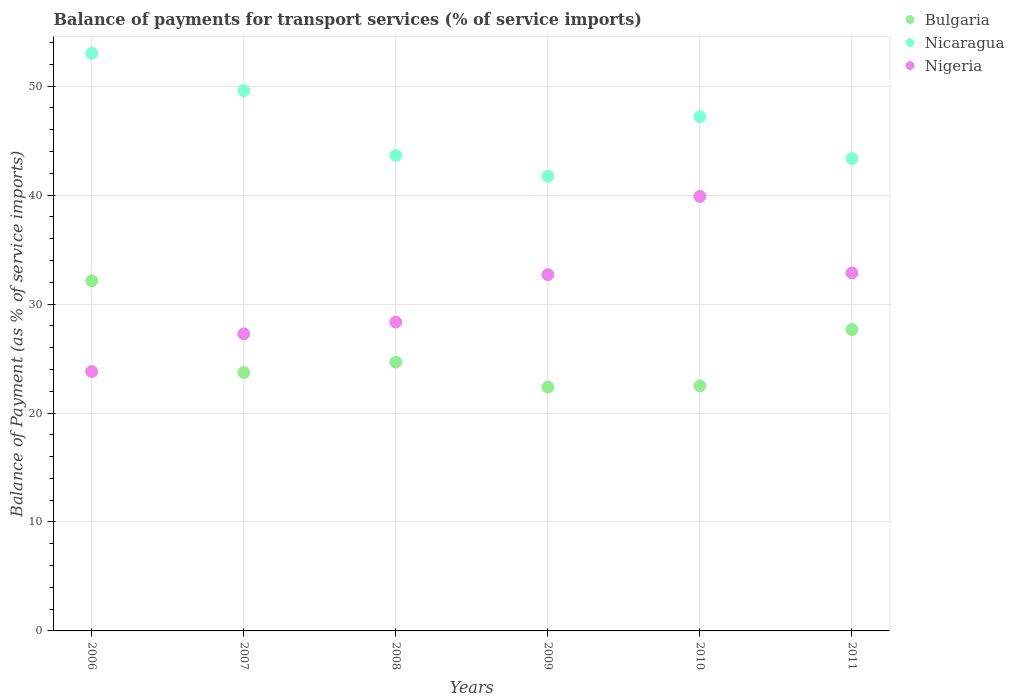What is the balance of payments for transport services in Nigeria in 2008?
Offer a terse response. 28.34. Across all years, what is the maximum balance of payments for transport services in Nigeria?
Keep it short and to the point. 39.87. Across all years, what is the minimum balance of payments for transport services in Bulgaria?
Your response must be concise. 22.37. In which year was the balance of payments for transport services in Nigeria maximum?
Your answer should be very brief. 2010. In which year was the balance of payments for transport services in Nicaragua minimum?
Provide a succinct answer. 2009. What is the total balance of payments for transport services in Nicaragua in the graph?
Offer a terse response. 278.52. What is the difference between the balance of payments for transport services in Nicaragua in 2006 and that in 2007?
Provide a short and direct response. 3.43. What is the difference between the balance of payments for transport services in Bulgaria in 2006 and the balance of payments for transport services in Nicaragua in 2008?
Offer a terse response. -11.5. What is the average balance of payments for transport services in Nicaragua per year?
Your answer should be very brief. 46.42. In the year 2011, what is the difference between the balance of payments for transport services in Nigeria and balance of payments for transport services in Bulgaria?
Provide a succinct answer. 5.19. In how many years, is the balance of payments for transport services in Nicaragua greater than 44 %?
Ensure brevity in your answer.  3. What is the ratio of the balance of payments for transport services in Nicaragua in 2007 to that in 2008?
Provide a succinct answer. 1.14. Is the balance of payments for transport services in Bulgaria in 2006 less than that in 2011?
Provide a short and direct response. No. What is the difference between the highest and the second highest balance of payments for transport services in Nicaragua?
Keep it short and to the point. 3.43. What is the difference between the highest and the lowest balance of payments for transport services in Nicaragua?
Give a very brief answer. 11.28. Is it the case that in every year, the sum of the balance of payments for transport services in Nigeria and balance of payments for transport services in Nicaragua  is greater than the balance of payments for transport services in Bulgaria?
Your answer should be compact. Yes. Is the balance of payments for transport services in Nicaragua strictly greater than the balance of payments for transport services in Nigeria over the years?
Offer a very short reply. Yes. Is the balance of payments for transport services in Nicaragua strictly less than the balance of payments for transport services in Nigeria over the years?
Ensure brevity in your answer.  No. How many years are there in the graph?
Your response must be concise. 6. Are the values on the major ticks of Y-axis written in scientific E-notation?
Your response must be concise. No. Does the graph contain any zero values?
Your answer should be compact. No. How many legend labels are there?
Provide a succinct answer. 3. How are the legend labels stacked?
Ensure brevity in your answer.  Vertical. What is the title of the graph?
Keep it short and to the point. Balance of payments for transport services (% of service imports). Does "Bhutan" appear as one of the legend labels in the graph?
Provide a short and direct response. No. What is the label or title of the Y-axis?
Your response must be concise. Balance of Payment (as % of service imports). What is the Balance of Payment (as % of service imports) of Bulgaria in 2006?
Offer a very short reply. 32.13. What is the Balance of Payment (as % of service imports) of Nicaragua in 2006?
Keep it short and to the point. 53.01. What is the Balance of Payment (as % of service imports) of Nigeria in 2006?
Offer a very short reply. 23.81. What is the Balance of Payment (as % of service imports) of Bulgaria in 2007?
Provide a succinct answer. 23.71. What is the Balance of Payment (as % of service imports) of Nicaragua in 2007?
Make the answer very short. 49.59. What is the Balance of Payment (as % of service imports) of Nigeria in 2007?
Your answer should be compact. 27.26. What is the Balance of Payment (as % of service imports) in Bulgaria in 2008?
Provide a succinct answer. 24.67. What is the Balance of Payment (as % of service imports) of Nicaragua in 2008?
Your response must be concise. 43.63. What is the Balance of Payment (as % of service imports) of Nigeria in 2008?
Keep it short and to the point. 28.34. What is the Balance of Payment (as % of service imports) in Bulgaria in 2009?
Your response must be concise. 22.37. What is the Balance of Payment (as % of service imports) of Nicaragua in 2009?
Offer a terse response. 41.73. What is the Balance of Payment (as % of service imports) of Nigeria in 2009?
Keep it short and to the point. 32.7. What is the Balance of Payment (as % of service imports) in Bulgaria in 2010?
Provide a short and direct response. 22.49. What is the Balance of Payment (as % of service imports) of Nicaragua in 2010?
Make the answer very short. 47.2. What is the Balance of Payment (as % of service imports) in Nigeria in 2010?
Your response must be concise. 39.87. What is the Balance of Payment (as % of service imports) of Bulgaria in 2011?
Provide a succinct answer. 27.66. What is the Balance of Payment (as % of service imports) of Nicaragua in 2011?
Ensure brevity in your answer.  43.35. What is the Balance of Payment (as % of service imports) of Nigeria in 2011?
Ensure brevity in your answer.  32.85. Across all years, what is the maximum Balance of Payment (as % of service imports) of Bulgaria?
Your answer should be very brief. 32.13. Across all years, what is the maximum Balance of Payment (as % of service imports) of Nicaragua?
Your response must be concise. 53.01. Across all years, what is the maximum Balance of Payment (as % of service imports) in Nigeria?
Your answer should be very brief. 39.87. Across all years, what is the minimum Balance of Payment (as % of service imports) of Bulgaria?
Provide a short and direct response. 22.37. Across all years, what is the minimum Balance of Payment (as % of service imports) in Nicaragua?
Offer a terse response. 41.73. Across all years, what is the minimum Balance of Payment (as % of service imports) in Nigeria?
Keep it short and to the point. 23.81. What is the total Balance of Payment (as % of service imports) of Bulgaria in the graph?
Ensure brevity in your answer.  153.04. What is the total Balance of Payment (as % of service imports) in Nicaragua in the graph?
Your response must be concise. 278.52. What is the total Balance of Payment (as % of service imports) in Nigeria in the graph?
Provide a succinct answer. 184.83. What is the difference between the Balance of Payment (as % of service imports) in Bulgaria in 2006 and that in 2007?
Keep it short and to the point. 8.42. What is the difference between the Balance of Payment (as % of service imports) in Nicaragua in 2006 and that in 2007?
Your answer should be very brief. 3.43. What is the difference between the Balance of Payment (as % of service imports) in Nigeria in 2006 and that in 2007?
Your answer should be compact. -3.45. What is the difference between the Balance of Payment (as % of service imports) of Bulgaria in 2006 and that in 2008?
Your response must be concise. 7.47. What is the difference between the Balance of Payment (as % of service imports) in Nicaragua in 2006 and that in 2008?
Offer a very short reply. 9.38. What is the difference between the Balance of Payment (as % of service imports) of Nigeria in 2006 and that in 2008?
Offer a terse response. -4.53. What is the difference between the Balance of Payment (as % of service imports) of Bulgaria in 2006 and that in 2009?
Ensure brevity in your answer.  9.76. What is the difference between the Balance of Payment (as % of service imports) in Nicaragua in 2006 and that in 2009?
Provide a short and direct response. 11.28. What is the difference between the Balance of Payment (as % of service imports) in Nigeria in 2006 and that in 2009?
Your response must be concise. -8.89. What is the difference between the Balance of Payment (as % of service imports) of Bulgaria in 2006 and that in 2010?
Your answer should be compact. 9.64. What is the difference between the Balance of Payment (as % of service imports) in Nicaragua in 2006 and that in 2010?
Your answer should be compact. 5.81. What is the difference between the Balance of Payment (as % of service imports) of Nigeria in 2006 and that in 2010?
Your response must be concise. -16.06. What is the difference between the Balance of Payment (as % of service imports) in Bulgaria in 2006 and that in 2011?
Provide a short and direct response. 4.47. What is the difference between the Balance of Payment (as % of service imports) in Nicaragua in 2006 and that in 2011?
Offer a terse response. 9.66. What is the difference between the Balance of Payment (as % of service imports) in Nigeria in 2006 and that in 2011?
Provide a short and direct response. -9.04. What is the difference between the Balance of Payment (as % of service imports) of Bulgaria in 2007 and that in 2008?
Your answer should be very brief. -0.96. What is the difference between the Balance of Payment (as % of service imports) of Nicaragua in 2007 and that in 2008?
Keep it short and to the point. 5.95. What is the difference between the Balance of Payment (as % of service imports) of Nigeria in 2007 and that in 2008?
Provide a short and direct response. -1.08. What is the difference between the Balance of Payment (as % of service imports) of Bulgaria in 2007 and that in 2009?
Ensure brevity in your answer.  1.34. What is the difference between the Balance of Payment (as % of service imports) of Nicaragua in 2007 and that in 2009?
Give a very brief answer. 7.86. What is the difference between the Balance of Payment (as % of service imports) in Nigeria in 2007 and that in 2009?
Provide a short and direct response. -5.43. What is the difference between the Balance of Payment (as % of service imports) of Bulgaria in 2007 and that in 2010?
Offer a very short reply. 1.22. What is the difference between the Balance of Payment (as % of service imports) in Nicaragua in 2007 and that in 2010?
Your response must be concise. 2.39. What is the difference between the Balance of Payment (as % of service imports) of Nigeria in 2007 and that in 2010?
Provide a short and direct response. -12.61. What is the difference between the Balance of Payment (as % of service imports) of Bulgaria in 2007 and that in 2011?
Give a very brief answer. -3.95. What is the difference between the Balance of Payment (as % of service imports) of Nicaragua in 2007 and that in 2011?
Give a very brief answer. 6.24. What is the difference between the Balance of Payment (as % of service imports) in Nigeria in 2007 and that in 2011?
Provide a short and direct response. -5.59. What is the difference between the Balance of Payment (as % of service imports) of Bulgaria in 2008 and that in 2009?
Your answer should be compact. 2.3. What is the difference between the Balance of Payment (as % of service imports) in Nicaragua in 2008 and that in 2009?
Keep it short and to the point. 1.9. What is the difference between the Balance of Payment (as % of service imports) of Nigeria in 2008 and that in 2009?
Make the answer very short. -4.35. What is the difference between the Balance of Payment (as % of service imports) of Bulgaria in 2008 and that in 2010?
Your answer should be compact. 2.18. What is the difference between the Balance of Payment (as % of service imports) of Nicaragua in 2008 and that in 2010?
Offer a very short reply. -3.57. What is the difference between the Balance of Payment (as % of service imports) of Nigeria in 2008 and that in 2010?
Offer a very short reply. -11.53. What is the difference between the Balance of Payment (as % of service imports) in Bulgaria in 2008 and that in 2011?
Ensure brevity in your answer.  -2.99. What is the difference between the Balance of Payment (as % of service imports) in Nicaragua in 2008 and that in 2011?
Provide a succinct answer. 0.28. What is the difference between the Balance of Payment (as % of service imports) in Nigeria in 2008 and that in 2011?
Make the answer very short. -4.51. What is the difference between the Balance of Payment (as % of service imports) of Bulgaria in 2009 and that in 2010?
Your response must be concise. -0.12. What is the difference between the Balance of Payment (as % of service imports) of Nicaragua in 2009 and that in 2010?
Give a very brief answer. -5.47. What is the difference between the Balance of Payment (as % of service imports) in Nigeria in 2009 and that in 2010?
Make the answer very short. -7.18. What is the difference between the Balance of Payment (as % of service imports) of Bulgaria in 2009 and that in 2011?
Provide a succinct answer. -5.29. What is the difference between the Balance of Payment (as % of service imports) in Nicaragua in 2009 and that in 2011?
Make the answer very short. -1.62. What is the difference between the Balance of Payment (as % of service imports) of Nigeria in 2009 and that in 2011?
Ensure brevity in your answer.  -0.16. What is the difference between the Balance of Payment (as % of service imports) of Bulgaria in 2010 and that in 2011?
Ensure brevity in your answer.  -5.17. What is the difference between the Balance of Payment (as % of service imports) of Nicaragua in 2010 and that in 2011?
Offer a very short reply. 3.85. What is the difference between the Balance of Payment (as % of service imports) of Nigeria in 2010 and that in 2011?
Give a very brief answer. 7.02. What is the difference between the Balance of Payment (as % of service imports) in Bulgaria in 2006 and the Balance of Payment (as % of service imports) in Nicaragua in 2007?
Offer a very short reply. -17.45. What is the difference between the Balance of Payment (as % of service imports) of Bulgaria in 2006 and the Balance of Payment (as % of service imports) of Nigeria in 2007?
Provide a short and direct response. 4.87. What is the difference between the Balance of Payment (as % of service imports) in Nicaragua in 2006 and the Balance of Payment (as % of service imports) in Nigeria in 2007?
Offer a terse response. 25.75. What is the difference between the Balance of Payment (as % of service imports) of Bulgaria in 2006 and the Balance of Payment (as % of service imports) of Nicaragua in 2008?
Offer a very short reply. -11.5. What is the difference between the Balance of Payment (as % of service imports) of Bulgaria in 2006 and the Balance of Payment (as % of service imports) of Nigeria in 2008?
Ensure brevity in your answer.  3.79. What is the difference between the Balance of Payment (as % of service imports) in Nicaragua in 2006 and the Balance of Payment (as % of service imports) in Nigeria in 2008?
Offer a terse response. 24.67. What is the difference between the Balance of Payment (as % of service imports) in Bulgaria in 2006 and the Balance of Payment (as % of service imports) in Nicaragua in 2009?
Your answer should be compact. -9.6. What is the difference between the Balance of Payment (as % of service imports) of Bulgaria in 2006 and the Balance of Payment (as % of service imports) of Nigeria in 2009?
Provide a succinct answer. -0.56. What is the difference between the Balance of Payment (as % of service imports) in Nicaragua in 2006 and the Balance of Payment (as % of service imports) in Nigeria in 2009?
Your answer should be compact. 20.32. What is the difference between the Balance of Payment (as % of service imports) in Bulgaria in 2006 and the Balance of Payment (as % of service imports) in Nicaragua in 2010?
Your response must be concise. -15.07. What is the difference between the Balance of Payment (as % of service imports) in Bulgaria in 2006 and the Balance of Payment (as % of service imports) in Nigeria in 2010?
Ensure brevity in your answer.  -7.74. What is the difference between the Balance of Payment (as % of service imports) of Nicaragua in 2006 and the Balance of Payment (as % of service imports) of Nigeria in 2010?
Your answer should be compact. 13.14. What is the difference between the Balance of Payment (as % of service imports) in Bulgaria in 2006 and the Balance of Payment (as % of service imports) in Nicaragua in 2011?
Your response must be concise. -11.22. What is the difference between the Balance of Payment (as % of service imports) in Bulgaria in 2006 and the Balance of Payment (as % of service imports) in Nigeria in 2011?
Provide a short and direct response. -0.72. What is the difference between the Balance of Payment (as % of service imports) in Nicaragua in 2006 and the Balance of Payment (as % of service imports) in Nigeria in 2011?
Provide a succinct answer. 20.16. What is the difference between the Balance of Payment (as % of service imports) of Bulgaria in 2007 and the Balance of Payment (as % of service imports) of Nicaragua in 2008?
Provide a short and direct response. -19.92. What is the difference between the Balance of Payment (as % of service imports) of Bulgaria in 2007 and the Balance of Payment (as % of service imports) of Nigeria in 2008?
Offer a terse response. -4.63. What is the difference between the Balance of Payment (as % of service imports) of Nicaragua in 2007 and the Balance of Payment (as % of service imports) of Nigeria in 2008?
Offer a very short reply. 21.25. What is the difference between the Balance of Payment (as % of service imports) of Bulgaria in 2007 and the Balance of Payment (as % of service imports) of Nicaragua in 2009?
Make the answer very short. -18.02. What is the difference between the Balance of Payment (as % of service imports) of Bulgaria in 2007 and the Balance of Payment (as % of service imports) of Nigeria in 2009?
Give a very brief answer. -8.98. What is the difference between the Balance of Payment (as % of service imports) of Nicaragua in 2007 and the Balance of Payment (as % of service imports) of Nigeria in 2009?
Ensure brevity in your answer.  16.89. What is the difference between the Balance of Payment (as % of service imports) of Bulgaria in 2007 and the Balance of Payment (as % of service imports) of Nicaragua in 2010?
Provide a short and direct response. -23.49. What is the difference between the Balance of Payment (as % of service imports) of Bulgaria in 2007 and the Balance of Payment (as % of service imports) of Nigeria in 2010?
Provide a short and direct response. -16.16. What is the difference between the Balance of Payment (as % of service imports) in Nicaragua in 2007 and the Balance of Payment (as % of service imports) in Nigeria in 2010?
Give a very brief answer. 9.72. What is the difference between the Balance of Payment (as % of service imports) in Bulgaria in 2007 and the Balance of Payment (as % of service imports) in Nicaragua in 2011?
Keep it short and to the point. -19.64. What is the difference between the Balance of Payment (as % of service imports) of Bulgaria in 2007 and the Balance of Payment (as % of service imports) of Nigeria in 2011?
Provide a short and direct response. -9.14. What is the difference between the Balance of Payment (as % of service imports) in Nicaragua in 2007 and the Balance of Payment (as % of service imports) in Nigeria in 2011?
Give a very brief answer. 16.74. What is the difference between the Balance of Payment (as % of service imports) in Bulgaria in 2008 and the Balance of Payment (as % of service imports) in Nicaragua in 2009?
Keep it short and to the point. -17.07. What is the difference between the Balance of Payment (as % of service imports) in Bulgaria in 2008 and the Balance of Payment (as % of service imports) in Nigeria in 2009?
Your response must be concise. -8.03. What is the difference between the Balance of Payment (as % of service imports) in Nicaragua in 2008 and the Balance of Payment (as % of service imports) in Nigeria in 2009?
Your response must be concise. 10.94. What is the difference between the Balance of Payment (as % of service imports) in Bulgaria in 2008 and the Balance of Payment (as % of service imports) in Nicaragua in 2010?
Ensure brevity in your answer.  -22.53. What is the difference between the Balance of Payment (as % of service imports) in Bulgaria in 2008 and the Balance of Payment (as % of service imports) in Nigeria in 2010?
Make the answer very short. -15.2. What is the difference between the Balance of Payment (as % of service imports) of Nicaragua in 2008 and the Balance of Payment (as % of service imports) of Nigeria in 2010?
Offer a very short reply. 3.76. What is the difference between the Balance of Payment (as % of service imports) of Bulgaria in 2008 and the Balance of Payment (as % of service imports) of Nicaragua in 2011?
Make the answer very short. -18.68. What is the difference between the Balance of Payment (as % of service imports) of Bulgaria in 2008 and the Balance of Payment (as % of service imports) of Nigeria in 2011?
Your answer should be very brief. -8.18. What is the difference between the Balance of Payment (as % of service imports) in Nicaragua in 2008 and the Balance of Payment (as % of service imports) in Nigeria in 2011?
Offer a very short reply. 10.78. What is the difference between the Balance of Payment (as % of service imports) of Bulgaria in 2009 and the Balance of Payment (as % of service imports) of Nicaragua in 2010?
Your response must be concise. -24.83. What is the difference between the Balance of Payment (as % of service imports) in Bulgaria in 2009 and the Balance of Payment (as % of service imports) in Nigeria in 2010?
Provide a succinct answer. -17.5. What is the difference between the Balance of Payment (as % of service imports) of Nicaragua in 2009 and the Balance of Payment (as % of service imports) of Nigeria in 2010?
Provide a short and direct response. 1.86. What is the difference between the Balance of Payment (as % of service imports) in Bulgaria in 2009 and the Balance of Payment (as % of service imports) in Nicaragua in 2011?
Provide a succinct answer. -20.98. What is the difference between the Balance of Payment (as % of service imports) of Bulgaria in 2009 and the Balance of Payment (as % of service imports) of Nigeria in 2011?
Your answer should be very brief. -10.48. What is the difference between the Balance of Payment (as % of service imports) in Nicaragua in 2009 and the Balance of Payment (as % of service imports) in Nigeria in 2011?
Ensure brevity in your answer.  8.88. What is the difference between the Balance of Payment (as % of service imports) in Bulgaria in 2010 and the Balance of Payment (as % of service imports) in Nicaragua in 2011?
Ensure brevity in your answer.  -20.86. What is the difference between the Balance of Payment (as % of service imports) of Bulgaria in 2010 and the Balance of Payment (as % of service imports) of Nigeria in 2011?
Your answer should be very brief. -10.36. What is the difference between the Balance of Payment (as % of service imports) in Nicaragua in 2010 and the Balance of Payment (as % of service imports) in Nigeria in 2011?
Your answer should be very brief. 14.35. What is the average Balance of Payment (as % of service imports) of Bulgaria per year?
Your response must be concise. 25.51. What is the average Balance of Payment (as % of service imports) of Nicaragua per year?
Keep it short and to the point. 46.42. What is the average Balance of Payment (as % of service imports) of Nigeria per year?
Your answer should be very brief. 30.8. In the year 2006, what is the difference between the Balance of Payment (as % of service imports) in Bulgaria and Balance of Payment (as % of service imports) in Nicaragua?
Provide a succinct answer. -20.88. In the year 2006, what is the difference between the Balance of Payment (as % of service imports) in Bulgaria and Balance of Payment (as % of service imports) in Nigeria?
Offer a terse response. 8.33. In the year 2006, what is the difference between the Balance of Payment (as % of service imports) in Nicaragua and Balance of Payment (as % of service imports) in Nigeria?
Offer a terse response. 29.21. In the year 2007, what is the difference between the Balance of Payment (as % of service imports) of Bulgaria and Balance of Payment (as % of service imports) of Nicaragua?
Your answer should be very brief. -25.88. In the year 2007, what is the difference between the Balance of Payment (as % of service imports) in Bulgaria and Balance of Payment (as % of service imports) in Nigeria?
Your answer should be very brief. -3.55. In the year 2007, what is the difference between the Balance of Payment (as % of service imports) of Nicaragua and Balance of Payment (as % of service imports) of Nigeria?
Your response must be concise. 22.33. In the year 2008, what is the difference between the Balance of Payment (as % of service imports) of Bulgaria and Balance of Payment (as % of service imports) of Nicaragua?
Your answer should be very brief. -18.97. In the year 2008, what is the difference between the Balance of Payment (as % of service imports) of Bulgaria and Balance of Payment (as % of service imports) of Nigeria?
Keep it short and to the point. -3.67. In the year 2008, what is the difference between the Balance of Payment (as % of service imports) in Nicaragua and Balance of Payment (as % of service imports) in Nigeria?
Provide a succinct answer. 15.29. In the year 2009, what is the difference between the Balance of Payment (as % of service imports) of Bulgaria and Balance of Payment (as % of service imports) of Nicaragua?
Ensure brevity in your answer.  -19.36. In the year 2009, what is the difference between the Balance of Payment (as % of service imports) in Bulgaria and Balance of Payment (as % of service imports) in Nigeria?
Provide a succinct answer. -10.32. In the year 2009, what is the difference between the Balance of Payment (as % of service imports) of Nicaragua and Balance of Payment (as % of service imports) of Nigeria?
Your answer should be very brief. 9.04. In the year 2010, what is the difference between the Balance of Payment (as % of service imports) in Bulgaria and Balance of Payment (as % of service imports) in Nicaragua?
Provide a short and direct response. -24.71. In the year 2010, what is the difference between the Balance of Payment (as % of service imports) of Bulgaria and Balance of Payment (as % of service imports) of Nigeria?
Provide a succinct answer. -17.38. In the year 2010, what is the difference between the Balance of Payment (as % of service imports) in Nicaragua and Balance of Payment (as % of service imports) in Nigeria?
Your answer should be very brief. 7.33. In the year 2011, what is the difference between the Balance of Payment (as % of service imports) in Bulgaria and Balance of Payment (as % of service imports) in Nicaragua?
Keep it short and to the point. -15.69. In the year 2011, what is the difference between the Balance of Payment (as % of service imports) of Bulgaria and Balance of Payment (as % of service imports) of Nigeria?
Your answer should be very brief. -5.19. In the year 2011, what is the difference between the Balance of Payment (as % of service imports) in Nicaragua and Balance of Payment (as % of service imports) in Nigeria?
Provide a short and direct response. 10.5. What is the ratio of the Balance of Payment (as % of service imports) in Bulgaria in 2006 to that in 2007?
Provide a short and direct response. 1.36. What is the ratio of the Balance of Payment (as % of service imports) of Nicaragua in 2006 to that in 2007?
Your answer should be compact. 1.07. What is the ratio of the Balance of Payment (as % of service imports) in Nigeria in 2006 to that in 2007?
Give a very brief answer. 0.87. What is the ratio of the Balance of Payment (as % of service imports) in Bulgaria in 2006 to that in 2008?
Keep it short and to the point. 1.3. What is the ratio of the Balance of Payment (as % of service imports) of Nicaragua in 2006 to that in 2008?
Your answer should be very brief. 1.22. What is the ratio of the Balance of Payment (as % of service imports) in Nigeria in 2006 to that in 2008?
Keep it short and to the point. 0.84. What is the ratio of the Balance of Payment (as % of service imports) in Bulgaria in 2006 to that in 2009?
Ensure brevity in your answer.  1.44. What is the ratio of the Balance of Payment (as % of service imports) of Nicaragua in 2006 to that in 2009?
Provide a succinct answer. 1.27. What is the ratio of the Balance of Payment (as % of service imports) in Nigeria in 2006 to that in 2009?
Make the answer very short. 0.73. What is the ratio of the Balance of Payment (as % of service imports) in Bulgaria in 2006 to that in 2010?
Your answer should be very brief. 1.43. What is the ratio of the Balance of Payment (as % of service imports) in Nicaragua in 2006 to that in 2010?
Your answer should be very brief. 1.12. What is the ratio of the Balance of Payment (as % of service imports) in Nigeria in 2006 to that in 2010?
Give a very brief answer. 0.6. What is the ratio of the Balance of Payment (as % of service imports) of Bulgaria in 2006 to that in 2011?
Ensure brevity in your answer.  1.16. What is the ratio of the Balance of Payment (as % of service imports) in Nicaragua in 2006 to that in 2011?
Your response must be concise. 1.22. What is the ratio of the Balance of Payment (as % of service imports) of Nigeria in 2006 to that in 2011?
Keep it short and to the point. 0.72. What is the ratio of the Balance of Payment (as % of service imports) in Bulgaria in 2007 to that in 2008?
Make the answer very short. 0.96. What is the ratio of the Balance of Payment (as % of service imports) of Nicaragua in 2007 to that in 2008?
Keep it short and to the point. 1.14. What is the ratio of the Balance of Payment (as % of service imports) of Nigeria in 2007 to that in 2008?
Your answer should be very brief. 0.96. What is the ratio of the Balance of Payment (as % of service imports) of Bulgaria in 2007 to that in 2009?
Give a very brief answer. 1.06. What is the ratio of the Balance of Payment (as % of service imports) of Nicaragua in 2007 to that in 2009?
Provide a succinct answer. 1.19. What is the ratio of the Balance of Payment (as % of service imports) of Nigeria in 2007 to that in 2009?
Offer a very short reply. 0.83. What is the ratio of the Balance of Payment (as % of service imports) in Bulgaria in 2007 to that in 2010?
Your answer should be compact. 1.05. What is the ratio of the Balance of Payment (as % of service imports) of Nicaragua in 2007 to that in 2010?
Offer a terse response. 1.05. What is the ratio of the Balance of Payment (as % of service imports) of Nigeria in 2007 to that in 2010?
Give a very brief answer. 0.68. What is the ratio of the Balance of Payment (as % of service imports) in Bulgaria in 2007 to that in 2011?
Give a very brief answer. 0.86. What is the ratio of the Balance of Payment (as % of service imports) of Nicaragua in 2007 to that in 2011?
Your answer should be compact. 1.14. What is the ratio of the Balance of Payment (as % of service imports) in Nigeria in 2007 to that in 2011?
Provide a short and direct response. 0.83. What is the ratio of the Balance of Payment (as % of service imports) of Bulgaria in 2008 to that in 2009?
Your answer should be very brief. 1.1. What is the ratio of the Balance of Payment (as % of service imports) of Nicaragua in 2008 to that in 2009?
Ensure brevity in your answer.  1.05. What is the ratio of the Balance of Payment (as % of service imports) in Nigeria in 2008 to that in 2009?
Give a very brief answer. 0.87. What is the ratio of the Balance of Payment (as % of service imports) of Bulgaria in 2008 to that in 2010?
Your response must be concise. 1.1. What is the ratio of the Balance of Payment (as % of service imports) in Nicaragua in 2008 to that in 2010?
Provide a succinct answer. 0.92. What is the ratio of the Balance of Payment (as % of service imports) in Nigeria in 2008 to that in 2010?
Offer a very short reply. 0.71. What is the ratio of the Balance of Payment (as % of service imports) of Bulgaria in 2008 to that in 2011?
Provide a succinct answer. 0.89. What is the ratio of the Balance of Payment (as % of service imports) in Nigeria in 2008 to that in 2011?
Provide a succinct answer. 0.86. What is the ratio of the Balance of Payment (as % of service imports) of Bulgaria in 2009 to that in 2010?
Your answer should be compact. 0.99. What is the ratio of the Balance of Payment (as % of service imports) in Nicaragua in 2009 to that in 2010?
Keep it short and to the point. 0.88. What is the ratio of the Balance of Payment (as % of service imports) of Nigeria in 2009 to that in 2010?
Offer a very short reply. 0.82. What is the ratio of the Balance of Payment (as % of service imports) of Bulgaria in 2009 to that in 2011?
Provide a short and direct response. 0.81. What is the ratio of the Balance of Payment (as % of service imports) of Nicaragua in 2009 to that in 2011?
Provide a short and direct response. 0.96. What is the ratio of the Balance of Payment (as % of service imports) of Nigeria in 2009 to that in 2011?
Your answer should be compact. 1. What is the ratio of the Balance of Payment (as % of service imports) of Bulgaria in 2010 to that in 2011?
Offer a very short reply. 0.81. What is the ratio of the Balance of Payment (as % of service imports) in Nicaragua in 2010 to that in 2011?
Make the answer very short. 1.09. What is the ratio of the Balance of Payment (as % of service imports) of Nigeria in 2010 to that in 2011?
Give a very brief answer. 1.21. What is the difference between the highest and the second highest Balance of Payment (as % of service imports) of Bulgaria?
Provide a succinct answer. 4.47. What is the difference between the highest and the second highest Balance of Payment (as % of service imports) in Nicaragua?
Your answer should be compact. 3.43. What is the difference between the highest and the second highest Balance of Payment (as % of service imports) in Nigeria?
Your answer should be very brief. 7.02. What is the difference between the highest and the lowest Balance of Payment (as % of service imports) in Bulgaria?
Give a very brief answer. 9.76. What is the difference between the highest and the lowest Balance of Payment (as % of service imports) of Nicaragua?
Offer a terse response. 11.28. What is the difference between the highest and the lowest Balance of Payment (as % of service imports) of Nigeria?
Your answer should be very brief. 16.06. 